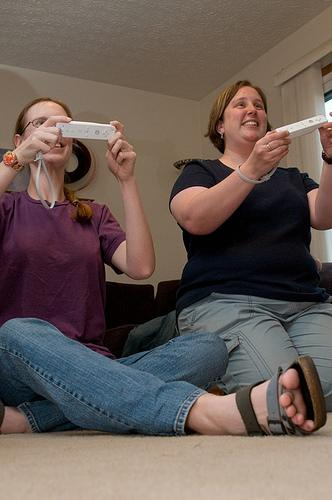What are these women looking at?

Choices:
A) mirror
B) car
C) monitor screen
D) rainbow monitor screen 